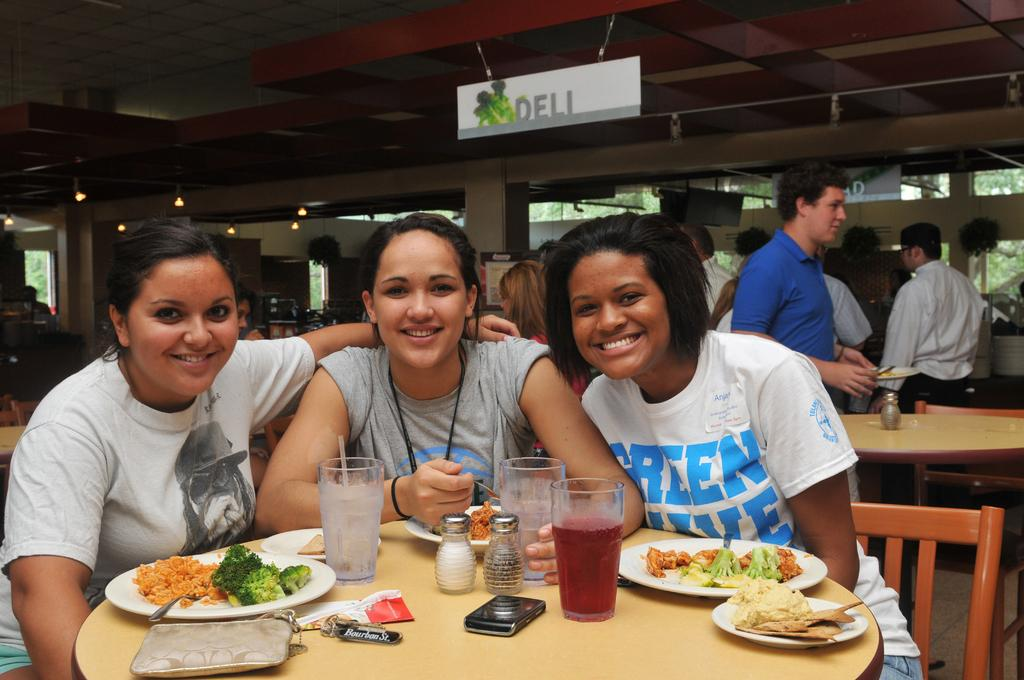How many people are in the image? There are three people in the image. What are the people doing in the image? The people are sitting in chairs. Where are the chairs located in relation to the table? The chairs are in front of the table. What can be found on the table in the image? There are food items, jars, and glasses on the table. Are there any other people in the image besides the ones sitting in chairs? Yes, there are people standing behind the table. Can you tell me what statement the beggar is making in the image? There is no beggar present in the image, and therefore no statement can be attributed to them. Is there a lake visible in the image? There is no lake present in the image. 